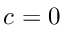<formula> <loc_0><loc_0><loc_500><loc_500>c = 0</formula> 